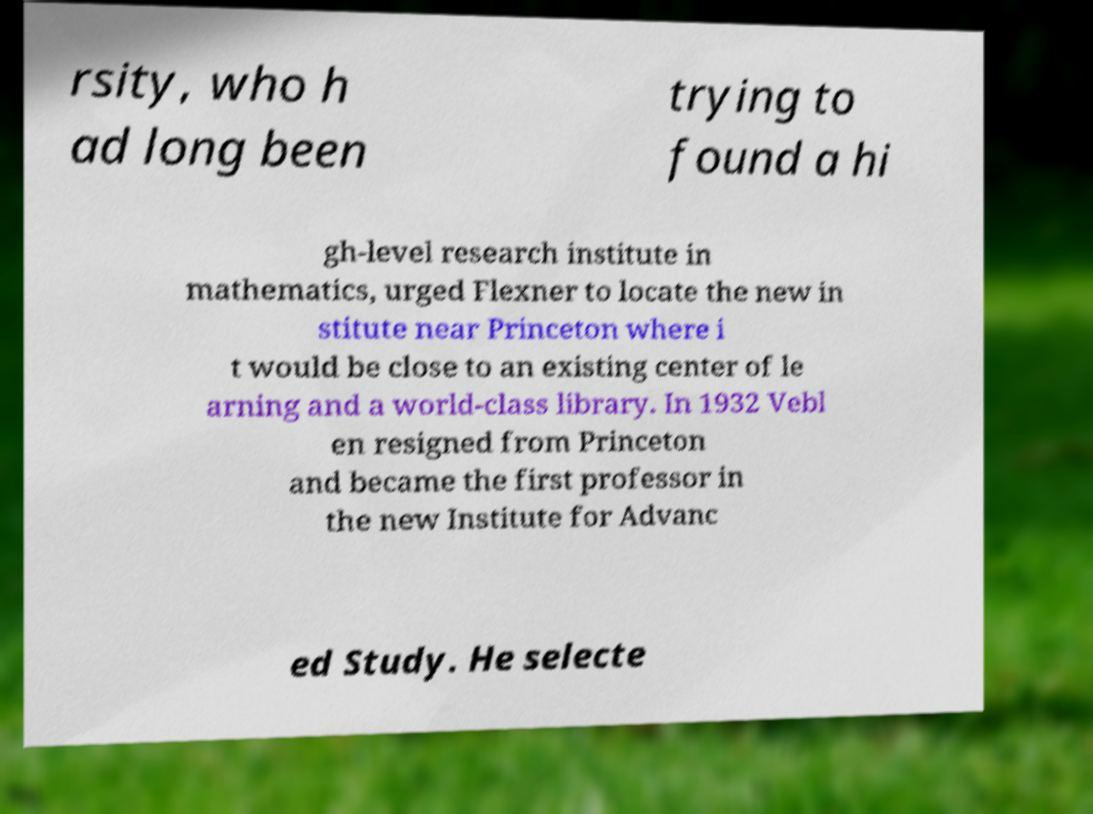What messages or text are displayed in this image? I need them in a readable, typed format. rsity, who h ad long been trying to found a hi gh-level research institute in mathematics, urged Flexner to locate the new in stitute near Princeton where i t would be close to an existing center of le arning and a world-class library. In 1932 Vebl en resigned from Princeton and became the first professor in the new Institute for Advanc ed Study. He selecte 